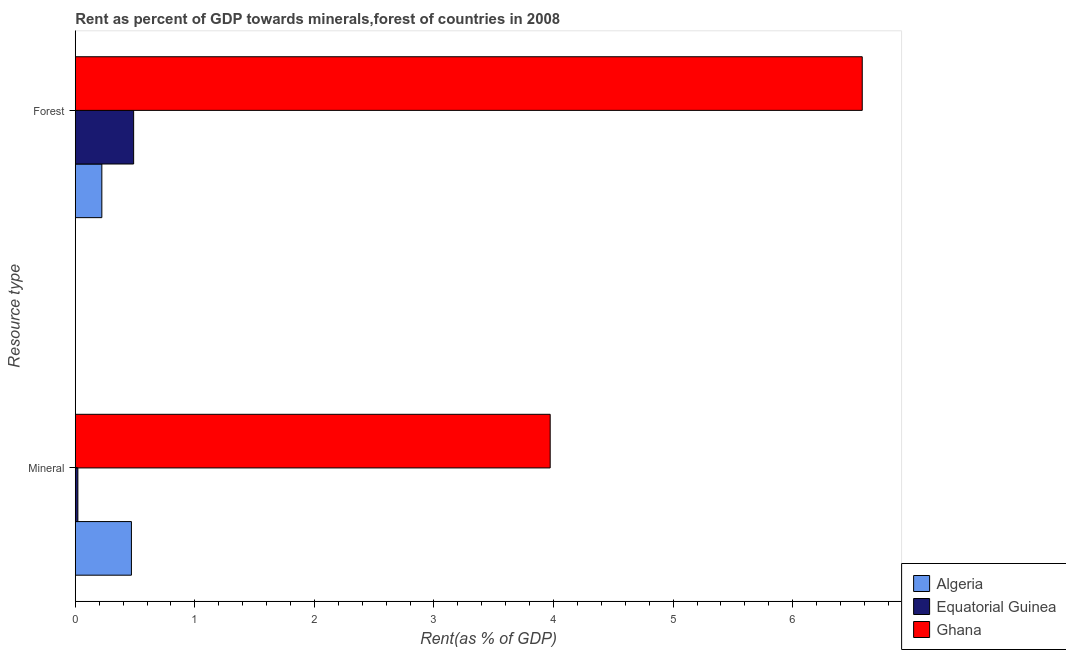How many different coloured bars are there?
Provide a succinct answer. 3. How many groups of bars are there?
Provide a short and direct response. 2. Are the number of bars per tick equal to the number of legend labels?
Your answer should be compact. Yes. How many bars are there on the 2nd tick from the bottom?
Keep it short and to the point. 3. What is the label of the 2nd group of bars from the top?
Offer a terse response. Mineral. What is the mineral rent in Ghana?
Provide a succinct answer. 3.97. Across all countries, what is the maximum forest rent?
Provide a succinct answer. 6.58. Across all countries, what is the minimum forest rent?
Make the answer very short. 0.22. In which country was the forest rent minimum?
Provide a short and direct response. Algeria. What is the total forest rent in the graph?
Provide a short and direct response. 7.29. What is the difference between the mineral rent in Equatorial Guinea and that in Ghana?
Your answer should be compact. -3.95. What is the difference between the forest rent in Equatorial Guinea and the mineral rent in Ghana?
Make the answer very short. -3.48. What is the average mineral rent per country?
Make the answer very short. 1.49. What is the difference between the mineral rent and forest rent in Equatorial Guinea?
Provide a succinct answer. -0.47. In how many countries, is the forest rent greater than 1.2 %?
Ensure brevity in your answer.  1. What is the ratio of the forest rent in Ghana to that in Algeria?
Give a very brief answer. 29.65. In how many countries, is the forest rent greater than the average forest rent taken over all countries?
Your answer should be very brief. 1. What does the 1st bar from the top in Mineral represents?
Keep it short and to the point. Ghana. What does the 2nd bar from the bottom in Mineral represents?
Offer a terse response. Equatorial Guinea. How many countries are there in the graph?
Offer a terse response. 3. What is the difference between two consecutive major ticks on the X-axis?
Make the answer very short. 1. Are the values on the major ticks of X-axis written in scientific E-notation?
Give a very brief answer. No. Does the graph contain any zero values?
Give a very brief answer. No. How many legend labels are there?
Your response must be concise. 3. What is the title of the graph?
Keep it short and to the point. Rent as percent of GDP towards minerals,forest of countries in 2008. What is the label or title of the X-axis?
Give a very brief answer. Rent(as % of GDP). What is the label or title of the Y-axis?
Keep it short and to the point. Resource type. What is the Rent(as % of GDP) of Algeria in Mineral?
Provide a succinct answer. 0.47. What is the Rent(as % of GDP) in Equatorial Guinea in Mineral?
Offer a terse response. 0.02. What is the Rent(as % of GDP) of Ghana in Mineral?
Your answer should be very brief. 3.97. What is the Rent(as % of GDP) of Algeria in Forest?
Your answer should be very brief. 0.22. What is the Rent(as % of GDP) of Equatorial Guinea in Forest?
Give a very brief answer. 0.49. What is the Rent(as % of GDP) of Ghana in Forest?
Your response must be concise. 6.58. Across all Resource type, what is the maximum Rent(as % of GDP) in Algeria?
Provide a short and direct response. 0.47. Across all Resource type, what is the maximum Rent(as % of GDP) of Equatorial Guinea?
Make the answer very short. 0.49. Across all Resource type, what is the maximum Rent(as % of GDP) of Ghana?
Offer a terse response. 6.58. Across all Resource type, what is the minimum Rent(as % of GDP) of Algeria?
Your response must be concise. 0.22. Across all Resource type, what is the minimum Rent(as % of GDP) of Equatorial Guinea?
Your response must be concise. 0.02. Across all Resource type, what is the minimum Rent(as % of GDP) in Ghana?
Offer a terse response. 3.97. What is the total Rent(as % of GDP) in Algeria in the graph?
Your answer should be very brief. 0.69. What is the total Rent(as % of GDP) in Equatorial Guinea in the graph?
Ensure brevity in your answer.  0.51. What is the total Rent(as % of GDP) in Ghana in the graph?
Offer a very short reply. 10.55. What is the difference between the Rent(as % of GDP) of Algeria in Mineral and that in Forest?
Give a very brief answer. 0.25. What is the difference between the Rent(as % of GDP) in Equatorial Guinea in Mineral and that in Forest?
Offer a terse response. -0.47. What is the difference between the Rent(as % of GDP) of Ghana in Mineral and that in Forest?
Make the answer very short. -2.61. What is the difference between the Rent(as % of GDP) of Algeria in Mineral and the Rent(as % of GDP) of Equatorial Guinea in Forest?
Give a very brief answer. -0.02. What is the difference between the Rent(as % of GDP) of Algeria in Mineral and the Rent(as % of GDP) of Ghana in Forest?
Make the answer very short. -6.11. What is the difference between the Rent(as % of GDP) of Equatorial Guinea in Mineral and the Rent(as % of GDP) of Ghana in Forest?
Offer a very short reply. -6.56. What is the average Rent(as % of GDP) in Algeria per Resource type?
Ensure brevity in your answer.  0.35. What is the average Rent(as % of GDP) in Equatorial Guinea per Resource type?
Provide a short and direct response. 0.25. What is the average Rent(as % of GDP) of Ghana per Resource type?
Make the answer very short. 5.28. What is the difference between the Rent(as % of GDP) in Algeria and Rent(as % of GDP) in Equatorial Guinea in Mineral?
Your answer should be very brief. 0.45. What is the difference between the Rent(as % of GDP) in Algeria and Rent(as % of GDP) in Ghana in Mineral?
Offer a very short reply. -3.5. What is the difference between the Rent(as % of GDP) of Equatorial Guinea and Rent(as % of GDP) of Ghana in Mineral?
Make the answer very short. -3.95. What is the difference between the Rent(as % of GDP) of Algeria and Rent(as % of GDP) of Equatorial Guinea in Forest?
Offer a terse response. -0.27. What is the difference between the Rent(as % of GDP) of Algeria and Rent(as % of GDP) of Ghana in Forest?
Offer a very short reply. -6.36. What is the difference between the Rent(as % of GDP) of Equatorial Guinea and Rent(as % of GDP) of Ghana in Forest?
Your answer should be compact. -6.09. What is the ratio of the Rent(as % of GDP) of Algeria in Mineral to that in Forest?
Give a very brief answer. 2.11. What is the ratio of the Rent(as % of GDP) of Equatorial Guinea in Mineral to that in Forest?
Give a very brief answer. 0.04. What is the ratio of the Rent(as % of GDP) in Ghana in Mineral to that in Forest?
Keep it short and to the point. 0.6. What is the difference between the highest and the second highest Rent(as % of GDP) of Algeria?
Keep it short and to the point. 0.25. What is the difference between the highest and the second highest Rent(as % of GDP) in Equatorial Guinea?
Your answer should be compact. 0.47. What is the difference between the highest and the second highest Rent(as % of GDP) in Ghana?
Offer a terse response. 2.61. What is the difference between the highest and the lowest Rent(as % of GDP) in Algeria?
Provide a succinct answer. 0.25. What is the difference between the highest and the lowest Rent(as % of GDP) of Equatorial Guinea?
Your answer should be very brief. 0.47. What is the difference between the highest and the lowest Rent(as % of GDP) of Ghana?
Your response must be concise. 2.61. 